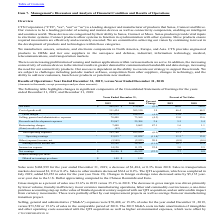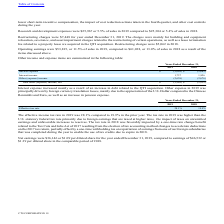From Cts Corporation's financial document, Which years does the table provide information for the company's Other income and expense items? The document shows two values: 2019 and 2018. From the document: "2019 2018 2019 2018..." Also, What was the primary reason for interest expense increase? mainly as a result of an increase in debt related to the QTI acquisition.. The document states: "Interest expense increased mainly as a result of an increase in debt related to the QTI acquisition. Other expense in 2019 was principally driven by f..." Also, What was Other expense in 2019 principally driven by? foreign currency translation losses, mainly due to the appreciation of the U.S. Dollar compared to the Chinese Renminbi and Euro, as well as an increase in pension expense.. The document states: "n. Other expense in 2019 was principally driven by foreign currency translation losses, mainly due to the appreciation of the U.S. Dollar compared to ..." Also, can you calculate: What was the change in Other (expense) income between 2018 and 2019? Based on the calculation: -2,638-(-2,676), the result is 38 (in thousands). This is based on the information: "Other (expense) income (2,638) (2,676) Other (expense) income (2,638) (2,676)..." The key data points involved are: 2,638, 2,676. Also, Which years did Interest income exceed $1,500 thousand? Counting the relevant items in the document: 2019, 2018, I find 2 instances. The key data points involved are: 2018, 2019. Also, can you calculate: What was the percentage change in interest income between 2018 and 2019? To answer this question, I need to perform calculations using the financial data. The calculation is: (1,737-1,826)/1,826, which equals -4.87 (percentage). This is based on the information: "Interest income 1,737 1,826 Interest income 1,737 1,826..." The key data points involved are: 1,737, 1,826. 